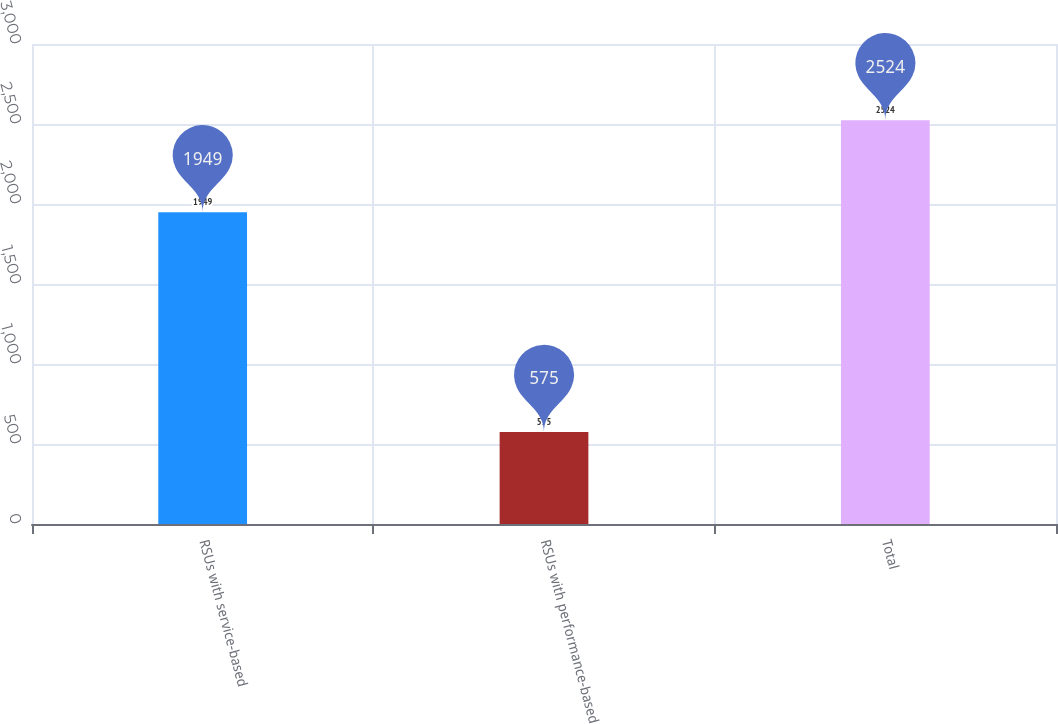Convert chart. <chart><loc_0><loc_0><loc_500><loc_500><bar_chart><fcel>RSUs with service-based<fcel>RSUs with performance-based<fcel>Total<nl><fcel>1949<fcel>575<fcel>2524<nl></chart> 